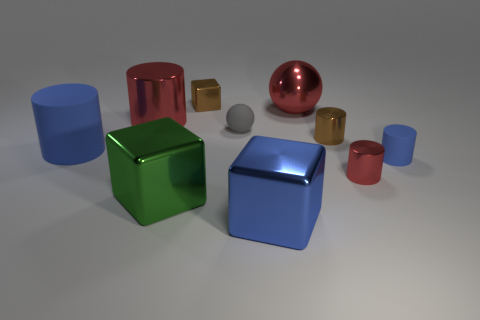Which objects in the image are reflective? The green cube, the blue cube, the red cylinder, the gold cube, and the silver sphere are all reflective, exhibiting shiny surfaces that appear to mirror their surroundings to some extent. 